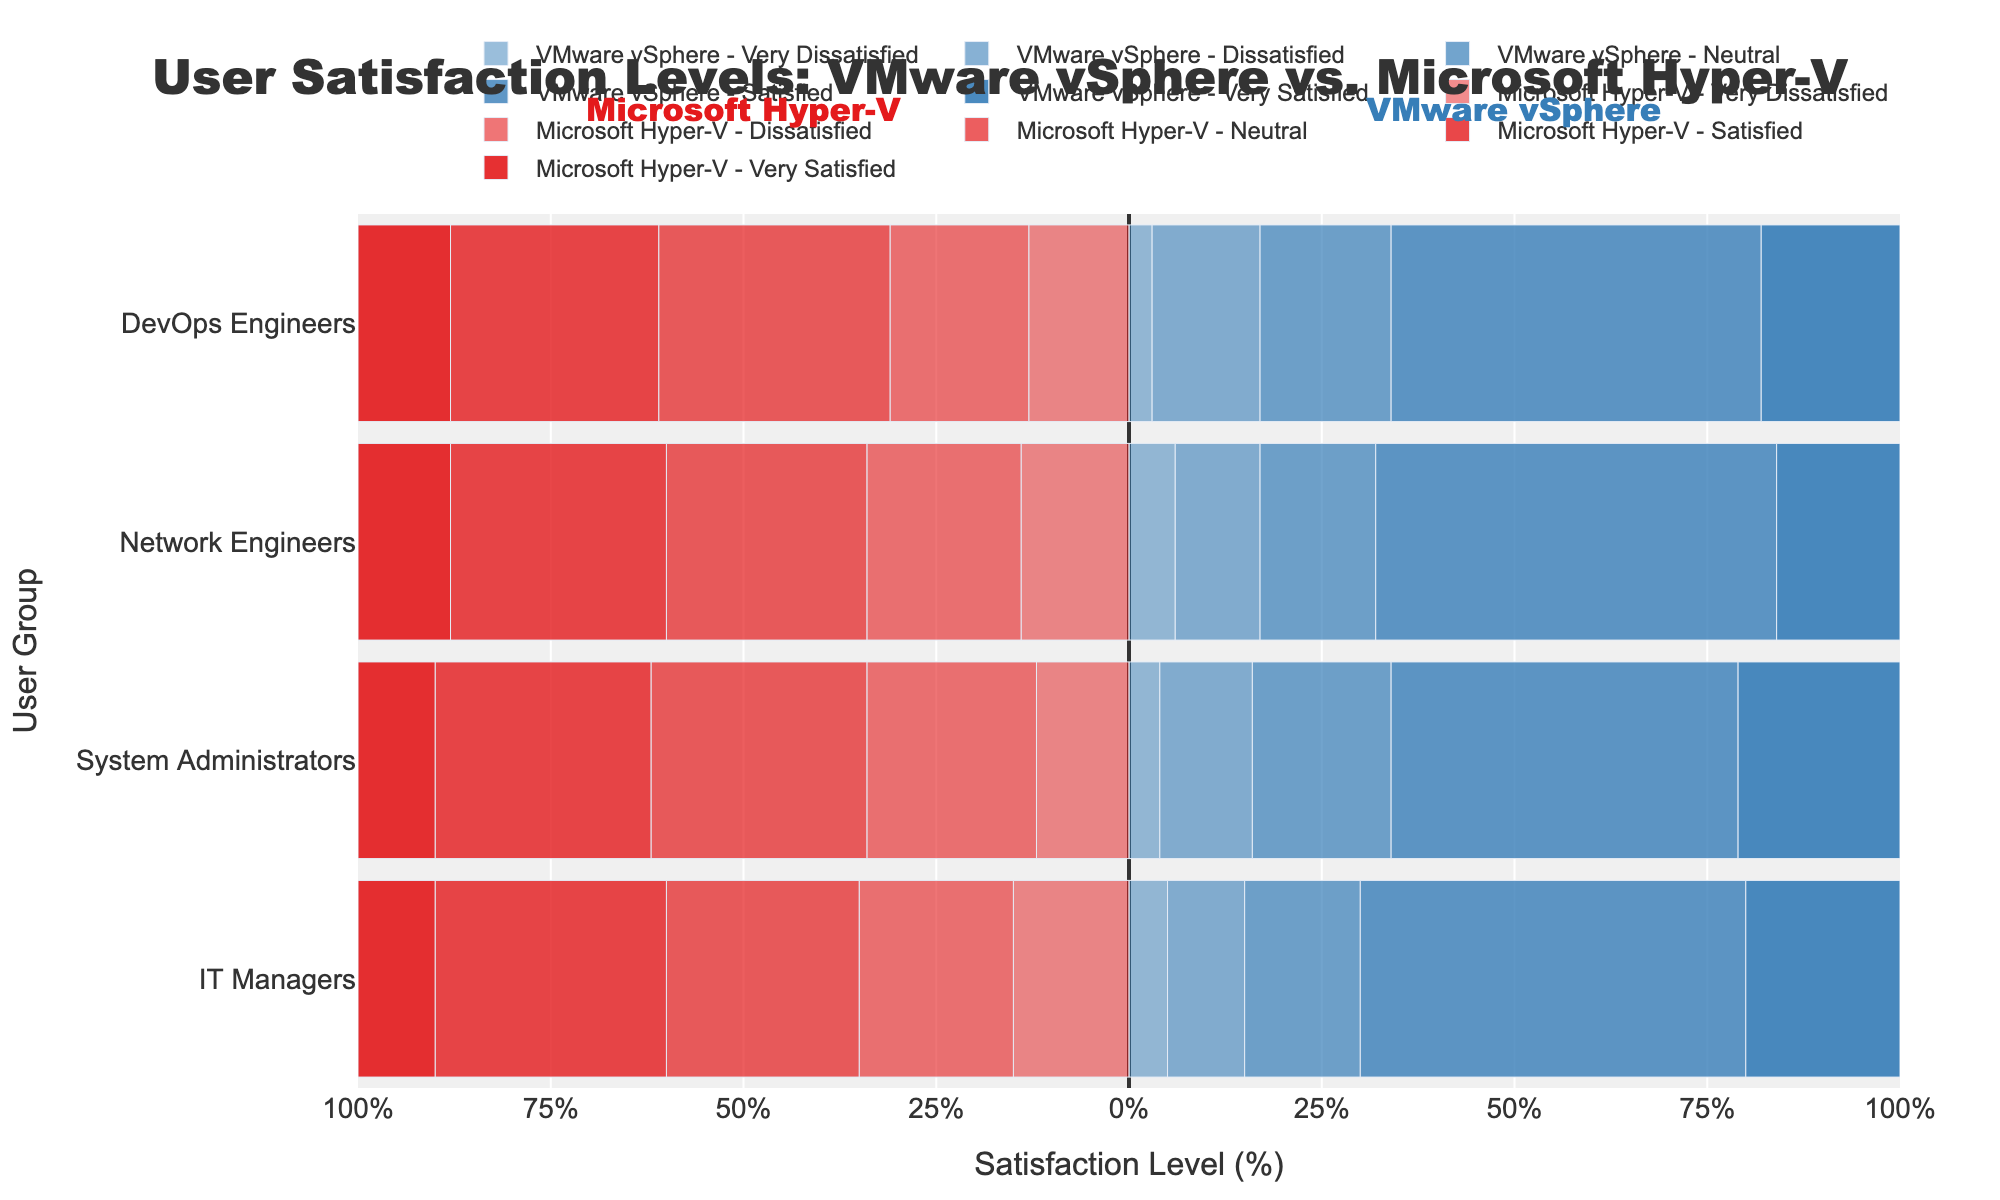What percentage of System Administrators are Neutral on Microsoft Hyper-V? Locate the "Neutral" category for Microsoft Hyper-V in the System Administrators row. The bar extends to -28%, which represents 28% satisfaction.
Answer: 28% Which user group has the highest percentage of respondents who are Very Satisfied with VMware vSphere? Look across the Very Satisfied columns for VMware vSphere for all user groups. System Administrators have the highest bar length, which corresponds to 21%.
Answer: System Administrators What is the total percentage of IT Managers who are Satisfied with either VMware vSphere or Microsoft Hyper-V? Add the percentages of IT Managers who are Satisfied with both VMware vSphere (50%) and Microsoft Hyper-V (30%). Total is 50% + 30% = 80%.
Answer: 80% What is the combined percentage of Network Engineers who are Dissatisfied and Very Dissatisfied with Microsoft Hyper-V? Add the percentages of Network Engineers who are Dissatisfied (20%) and Very Dissatisfied (14%) with Microsoft Hyper-V. Total is 20% + 14% = 34%.
Answer: 34% Which group has a larger percentage of Very Dissatisfied users for VMware vSphere compared to Microsoft Hyper-V? Compare the Very Dissatisfied percentages in each user group for VMware vSphere and Microsoft Hyper-V. None of the groups have a higher Very Dissatisfied percentage for VMware vSphere compared to Microsoft Hyper-V.
Answer: None Is the percentage of DevOps Engineers that are Very Satisfied with VMware vSphere greater than the percentage who are Neutral? Compare the Very Satisfied percentage (18%) with the Neutral percentage (17%) for DevOps Engineers using VMware vSphere. Since 18% > 17%, the answer is yes.
Answer: Yes Which user group has the smallest difference between Satisfied percentages for VMware vSphere and Microsoft Hyper-V? Calculate the difference in percentages for the Satisfied category for each group: IT Managers: 50%-30% = 20%, System Administrators: 45%-28% = 17%, Network Engineers: 52%-28% = 24%, DevOps Engineers: 48%-27% = 21%. System Administrators have the smallest difference of 17%.
Answer: System Administrators How do the percentages of Very Dissatisfied IT Managers compare between VMware vSphere and Microsoft Hyper-V? Compare the Very Dissatisfied percentages for IT Managers: VMware vSphere (5%) and Microsoft Hyper-V (15%). The percentage of Very Dissatisfied IT Managers is higher for Microsoft Hyper-V by 10%.
Answer: Higher by 10% What is the average percentage of Dissatisfied users across all groups for Microsoft Hyper-V? Calculate the average of Dissatisfied percentages for all groups in Microsoft Hyper-V: (20% IT Managers + 22% System Administrators + 20% Network Engineers + 18% DevOps Engineers) / 4 = 20%.
Answer: 20% 